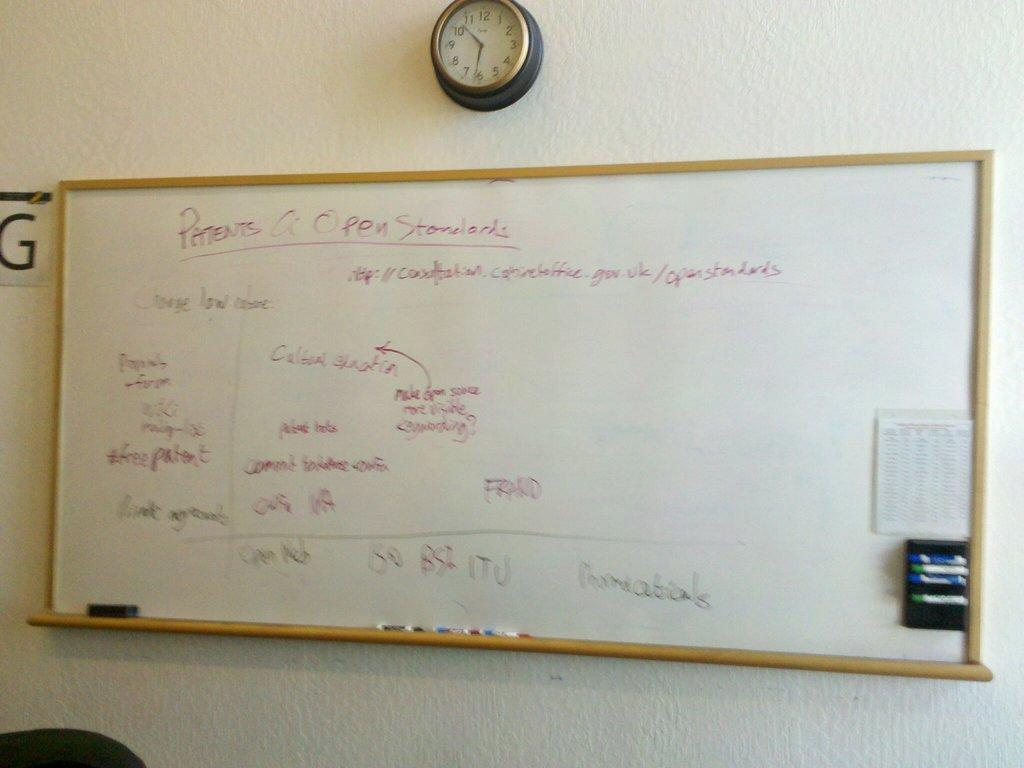<image>
Render a clear and concise summary of the photo. a patents name that is on a white board 